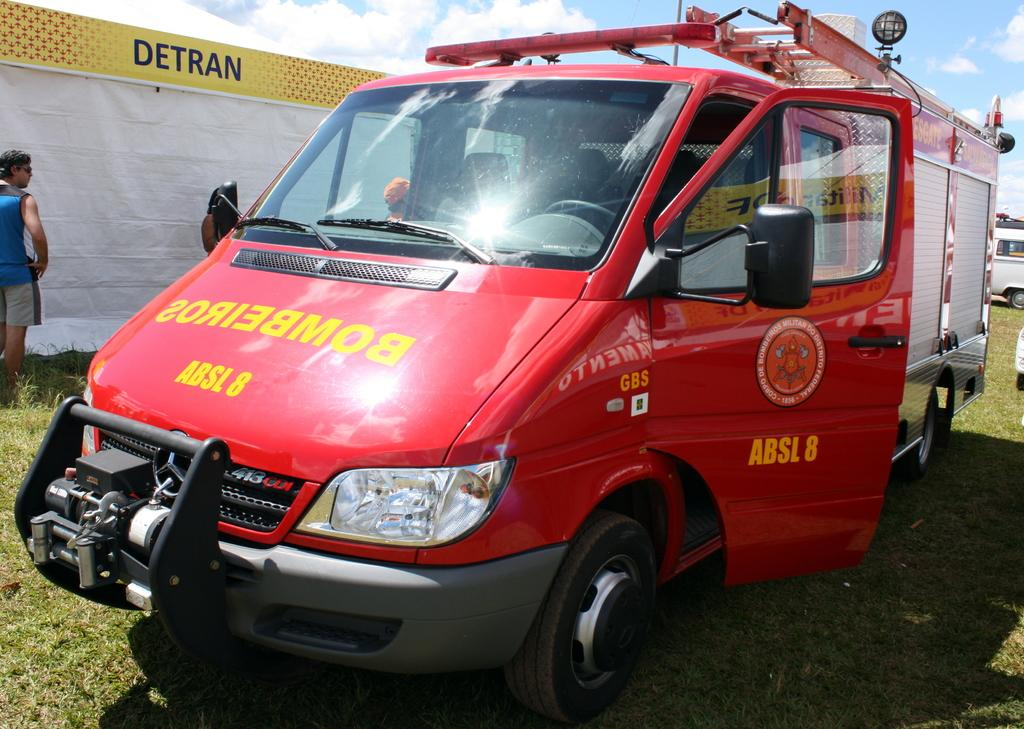Provide a one-sentence caption for the provided image. An ambulance is parked in front of a building with Detran on it. 